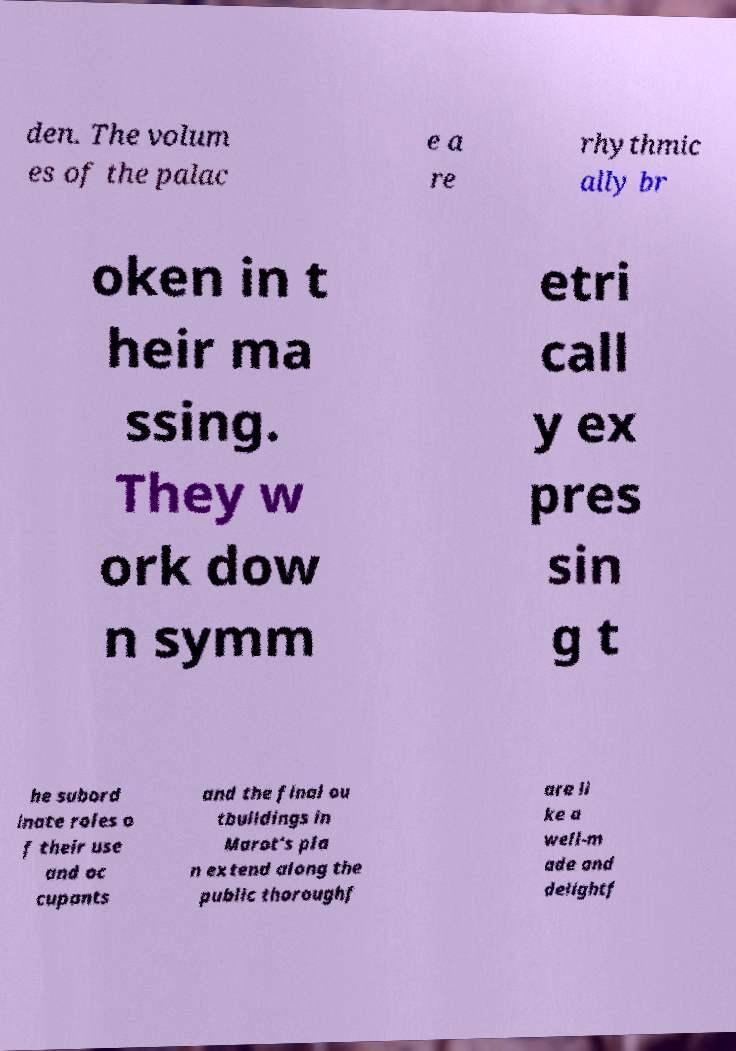Can you accurately transcribe the text from the provided image for me? den. The volum es of the palac e a re rhythmic ally br oken in t heir ma ssing. They w ork dow n symm etri call y ex pres sin g t he subord inate roles o f their use and oc cupants and the final ou tbuildings in Marot's pla n extend along the public thoroughf are li ke a well-m ade and delightf 